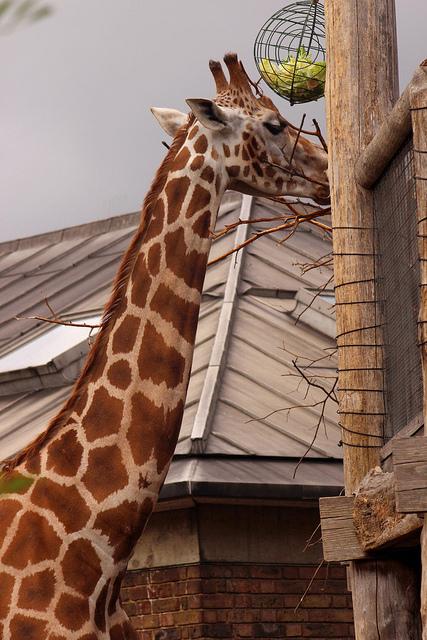Is the giraffe playing with tennis balls?
Short answer required. No. What direction is the giraffe looking?
Concise answer only. Right. Is a window shown in the photograph?
Be succinct. No. What is in the metal cage?
Concise answer only. Bananas. 